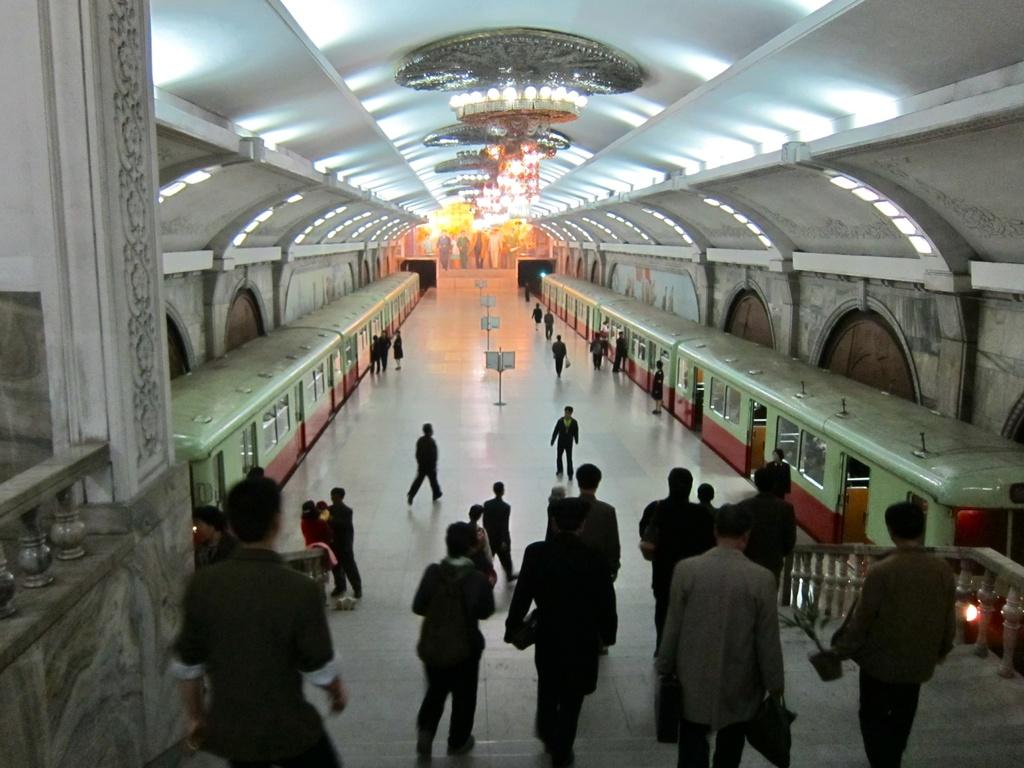Who or what can be seen in the image? A: There are people in the image. What type of vehicles are present in the image? There are trains in the image. What can be used for illumination in the image? There are lights in the image. What type of signage is present in the image? There are boards in the image. How can people move between different levels in the image? There are stairs in the image. What is the structure's upper boundary in the image? There is a roof at the top of the image. What is the structure's lower boundary in the image? There is a floor at the bottom of the image. Can you tell me how many feathers are attached to the country in the image? There is no country or feathers present in the image. How does the person in the image pull the train? There is no person pulling a train in the image; the trains are stationary. 